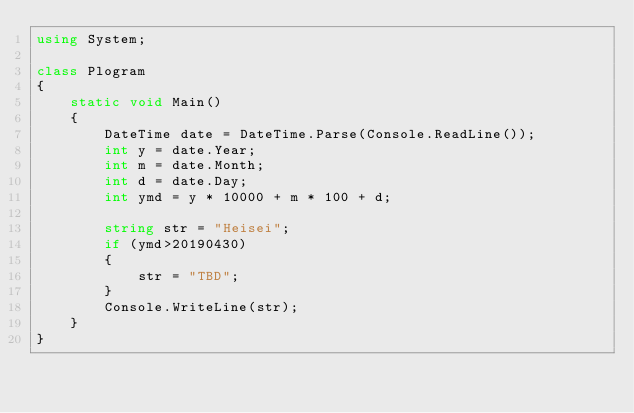<code> <loc_0><loc_0><loc_500><loc_500><_C#_>using System;

class Plogram
{
    static void Main()
    {
        DateTime date = DateTime.Parse(Console.ReadLine());
        int y = date.Year;
        int m = date.Month;
        int d = date.Day;
        int ymd = y * 10000 + m * 100 + d;

        string str = "Heisei";
        if (ymd>20190430)
        {
            str = "TBD";
        }
        Console.WriteLine(str);
    }
}</code> 